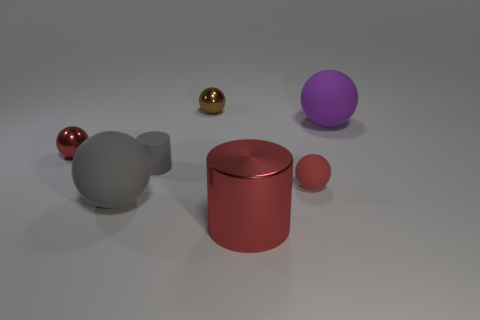Subtract all purple balls. How many balls are left? 4 Subtract all tiny brown spheres. How many spheres are left? 4 Subtract all green spheres. Subtract all cyan cubes. How many spheres are left? 5 Add 1 small gray cylinders. How many objects exist? 8 Subtract all cylinders. How many objects are left? 5 Add 4 large gray matte objects. How many large gray matte objects exist? 5 Subtract 0 green cylinders. How many objects are left? 7 Subtract all small yellow rubber blocks. Subtract all large gray rubber spheres. How many objects are left? 6 Add 3 rubber cylinders. How many rubber cylinders are left? 4 